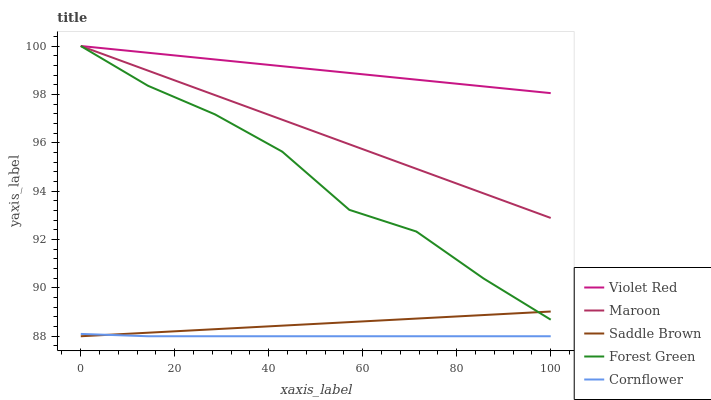Does Cornflower have the minimum area under the curve?
Answer yes or no. Yes. Does Violet Red have the maximum area under the curve?
Answer yes or no. Yes. Does Violet Red have the minimum area under the curve?
Answer yes or no. No. Does Cornflower have the maximum area under the curve?
Answer yes or no. No. Is Violet Red the smoothest?
Answer yes or no. Yes. Is Forest Green the roughest?
Answer yes or no. Yes. Is Cornflower the smoothest?
Answer yes or no. No. Is Cornflower the roughest?
Answer yes or no. No. Does Cornflower have the lowest value?
Answer yes or no. Yes. Does Violet Red have the lowest value?
Answer yes or no. No. Does Maroon have the highest value?
Answer yes or no. Yes. Does Cornflower have the highest value?
Answer yes or no. No. Is Saddle Brown less than Violet Red?
Answer yes or no. Yes. Is Violet Red greater than Saddle Brown?
Answer yes or no. Yes. Does Violet Red intersect Forest Green?
Answer yes or no. Yes. Is Violet Red less than Forest Green?
Answer yes or no. No. Is Violet Red greater than Forest Green?
Answer yes or no. No. Does Saddle Brown intersect Violet Red?
Answer yes or no. No. 